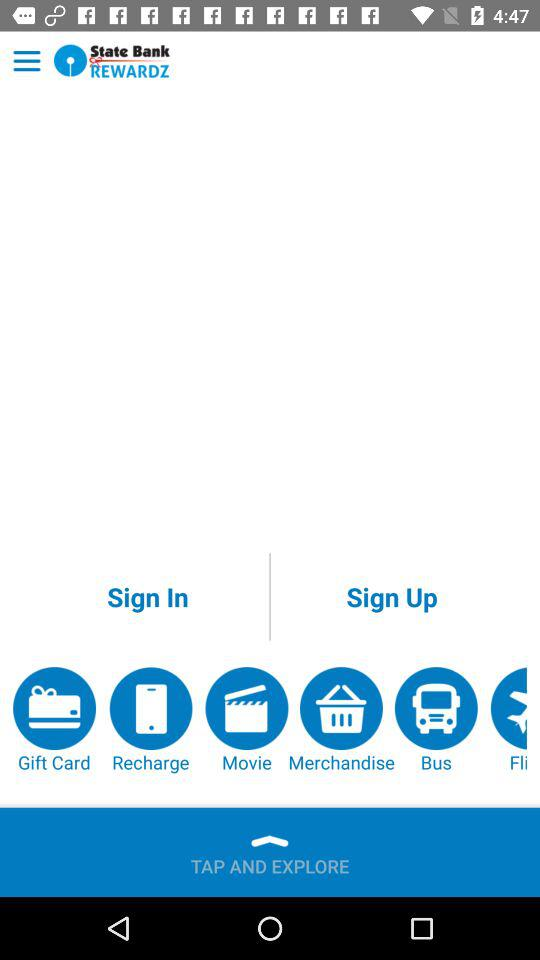What is the name of the application? The name of the application is "State Bank REWARDZ". 